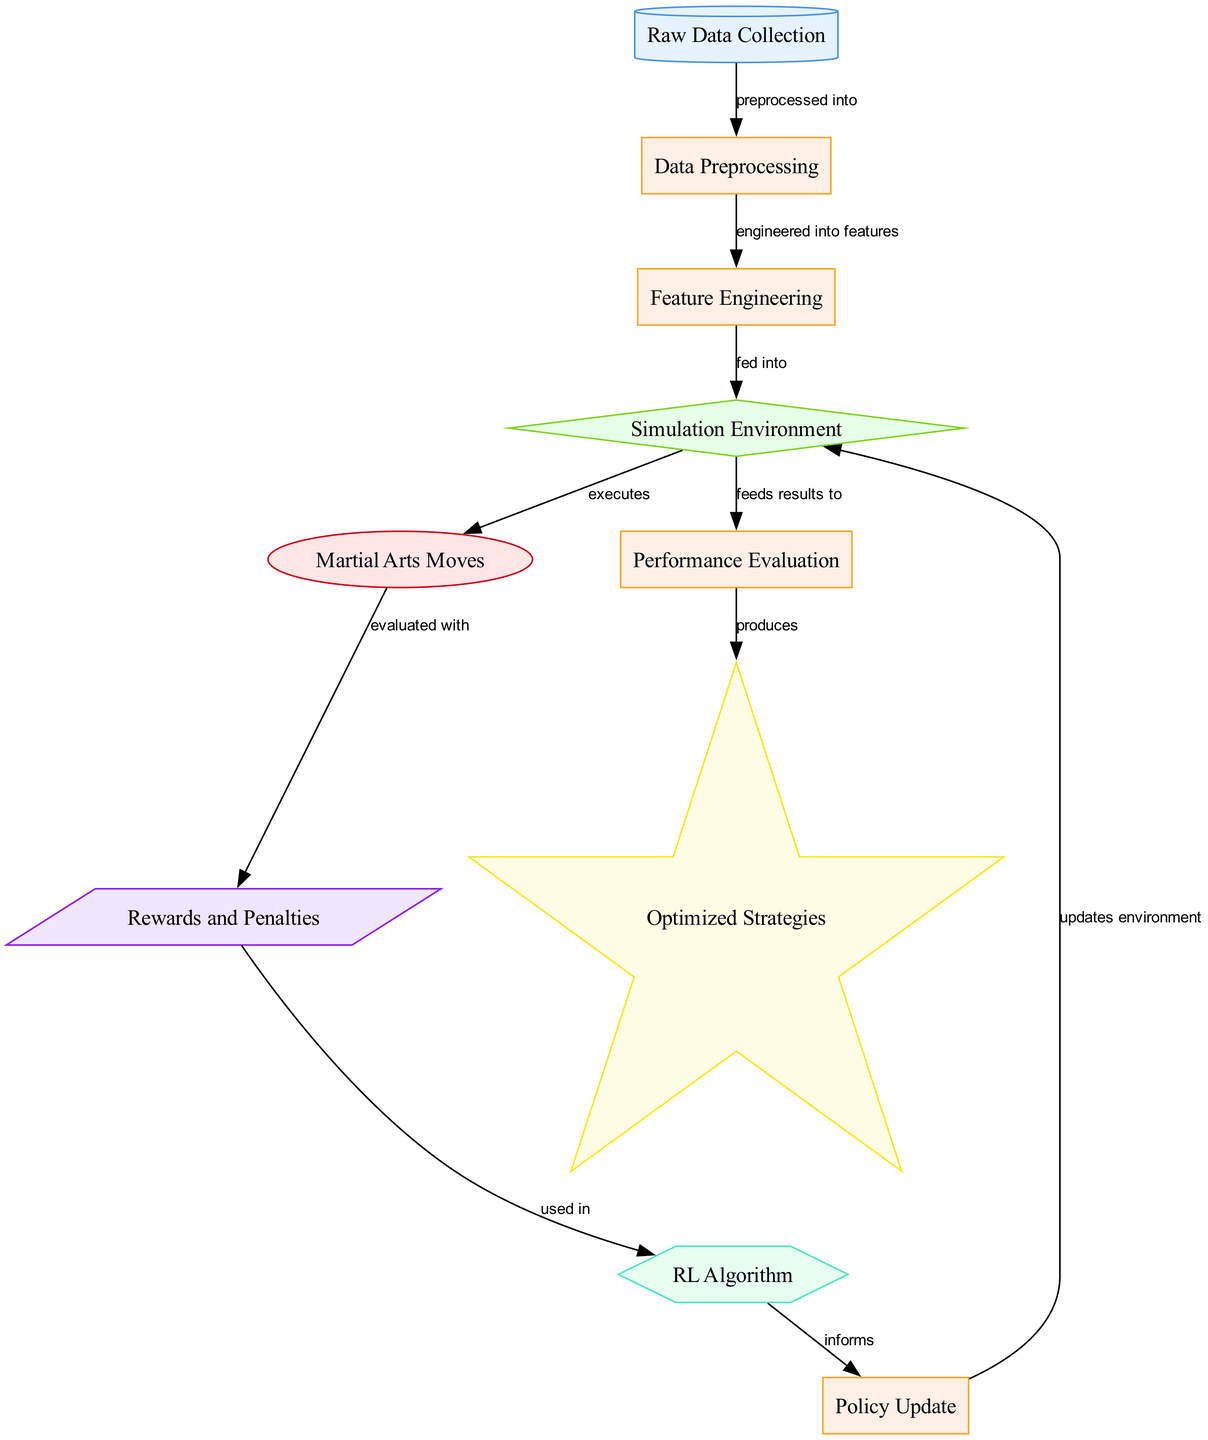What is the starting point of the diagram? The starting point is the "Raw Data Collection," which is the first node in the diagram.
Answer: Raw Data Collection How many nodes are there in total? The diagram includes ten distinct nodes, each representing a different component of the reinforcement learning process.
Answer: Ten What type of node is "Martial Arts Moves"? "Martial Arts Moves" is classified as an action node, indicating that it represents actions taken within the simulation environment.
Answer: action What process follows "Feature Engineering"? After "Feature Engineering," the next process is "Simulation Environment," as indicated by the directed edge in the flow of the diagram.
Answer: Simulation Environment Which metric is used to evaluate martial arts moves? The metric used is "Rewards and Penalties," which assesses the actions executed within the environment.
Answer: Rewards and Penalties Which node informs the "Policy Update"? The "RL Algorithm" informs the "Policy Update," indicating that the algorithm's outcomes guide how policies are adjusted.
Answer: RL Algorithm What is the final outcome of the diagram process? The final outcome of the diagram process is "Optimized Strategies," which represents the result produced after evaluation.
Answer: Optimized Strategies How do "Rewards and Penalties" contribute to the "RL Algorithm"? "Rewards and Penalties" are used as input for the "RL Algorithm," influencing its behavior and learning in the reinforcement learning process.
Answer: Used in What updates occur after "Policy Update"? The update occurs in the "Simulation Environment," indicating that the environment's state is modified based on the updated policy.
Answer: Updates environment 